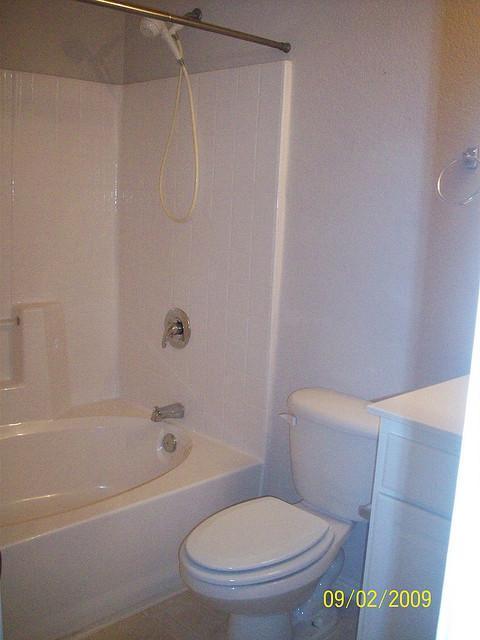How many people wears the blue jersey?
Give a very brief answer. 0. 